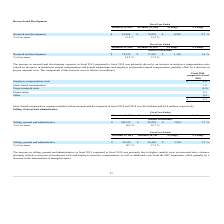According to Formfactor's financial document, What led to increase in selling, general and administrative in fiscal 2019 compared to fiscal 2018? The increase in selling, general and administrative in fiscal 2019 compared to fiscal 2018 was primarily due to higher variable costs on increased sales volumes. The document states: "The increase in selling, general and administrative in fiscal 2019 compared to fiscal 2018 was primarily due to higher variable costs on increased sal..." Also, can you calculate: What is the average Selling, general and administrative for the Fiscal Year Ended December 28, 2019 to December 29, 2018?   To answer this question, I need to perform calculations using the financial data. The calculation is: (106,335+99,254) / 2, which equals 102794.5 (in thousands). This is based on the information: "Selling, general and administrative $ 106,335 $ 99,254 $ 7,081 7.1 % Selling, general and administrative $ 106,335 $ 99,254 $ 7,081 7.1 %..." The key data points involved are: 106,335, 99,254. Also, can you calculate: What is the average Selling, general and administrative for the Fiscal Year Ended December 29, 2018 to December 30, 2017? To answer this question, I need to perform calculations using the financial data. The calculation is: (99,254+95,489) / 2, which equals 97371.5 (in thousands). This is based on the information: "Selling, general and administrative $ 99,254 $ 95,489 $ 3,765 3.9 % Selling, general and administrative $ 106,335 $ 99,254 $ 7,081 7.1 %..." The key data points involved are: 95,489, 99,254. Additionally, In which year was Selling, general and administrative less than 100,000 thousands? The document shows two values: 2018 and 2017. Locate and analyze the selling, general and administrative in row 4. From the document: "December 29, 2018 December 30, 2017 $ Change % Change December 29, 2018 December 30, 2017 $ Change % Change..." Also, What is the percentage of revenue in 2019 and 2018? The document contains multiple relevant values: 18.0, 18.7,  (percentage). From the document: "% of revenues 18.0 % 18.7 % % of revenues 18.0 % 18.7 % % of revenues 18.0 % 18.7 %..." Also, What was the Selling, general and administrative in 2018 and 2017? The document shows two values: 99,254 and 95,489 (in thousands). From the document: "Selling, general and administrative $ 99,254 $ 95,489 $ 3,765 3.9 % Selling, general and administrative $ 106,335 $ 99,254 $ 7,081 7.1 %..." 